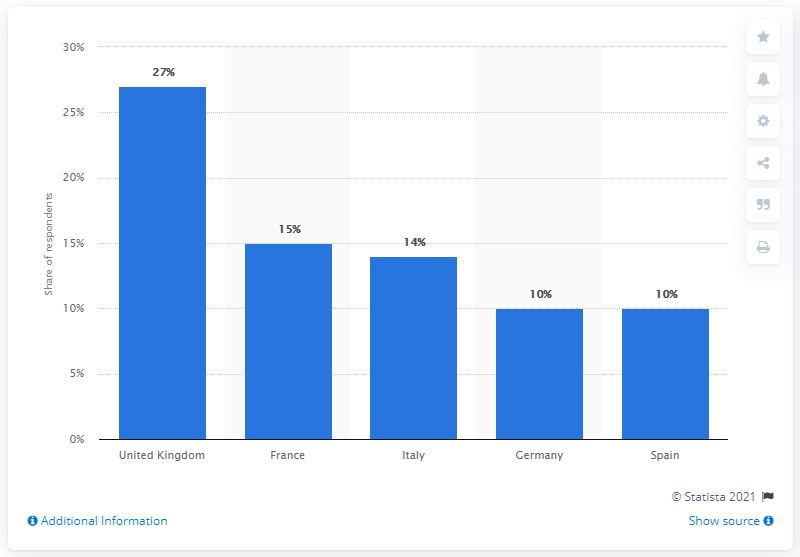Give some essential details in this illustration. According to the survey, France had the largest percentage of respondents who are now eating less healthily due to the COVID-19 pandemic. 